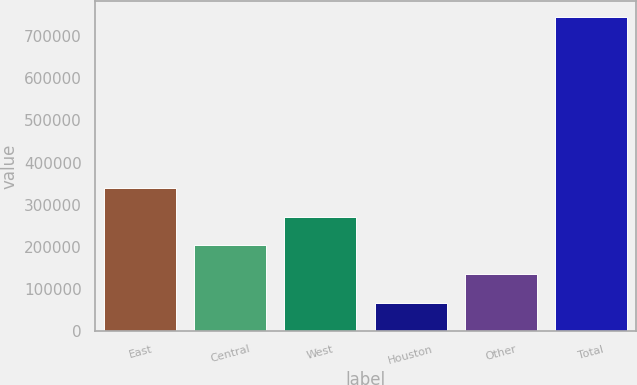Convert chart. <chart><loc_0><loc_0><loc_500><loc_500><bar_chart><fcel>East<fcel>Central<fcel>West<fcel>Houston<fcel>Other<fcel>Total<nl><fcel>339052<fcel>203230<fcel>271141<fcel>67408<fcel>135319<fcel>746518<nl></chart> 